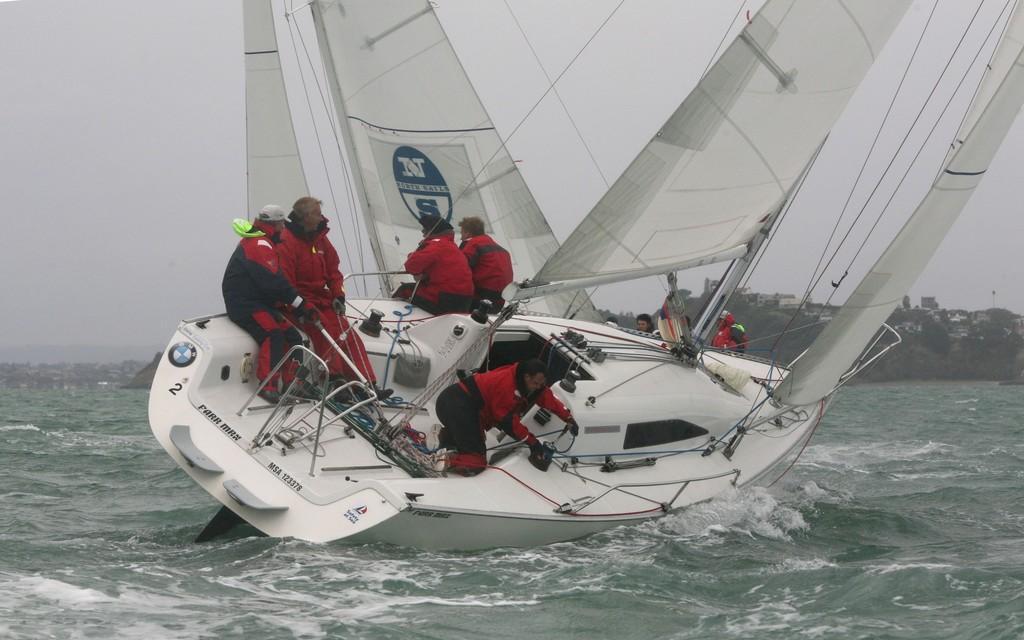In one or two sentences, can you explain what this image depicts? In this image there is the sky truncated towards the top of the image, there is water truncated towards the bottom of the image, there is water truncated towards the left of the image, there is water truncated towards the right of the image, there is a boat truncated towards the top of the image, there are persons in the boat, there is an object truncated towards the right of the image, there is an object truncated towards the left of the image, there is text on the boat, the persons are holding an object. 